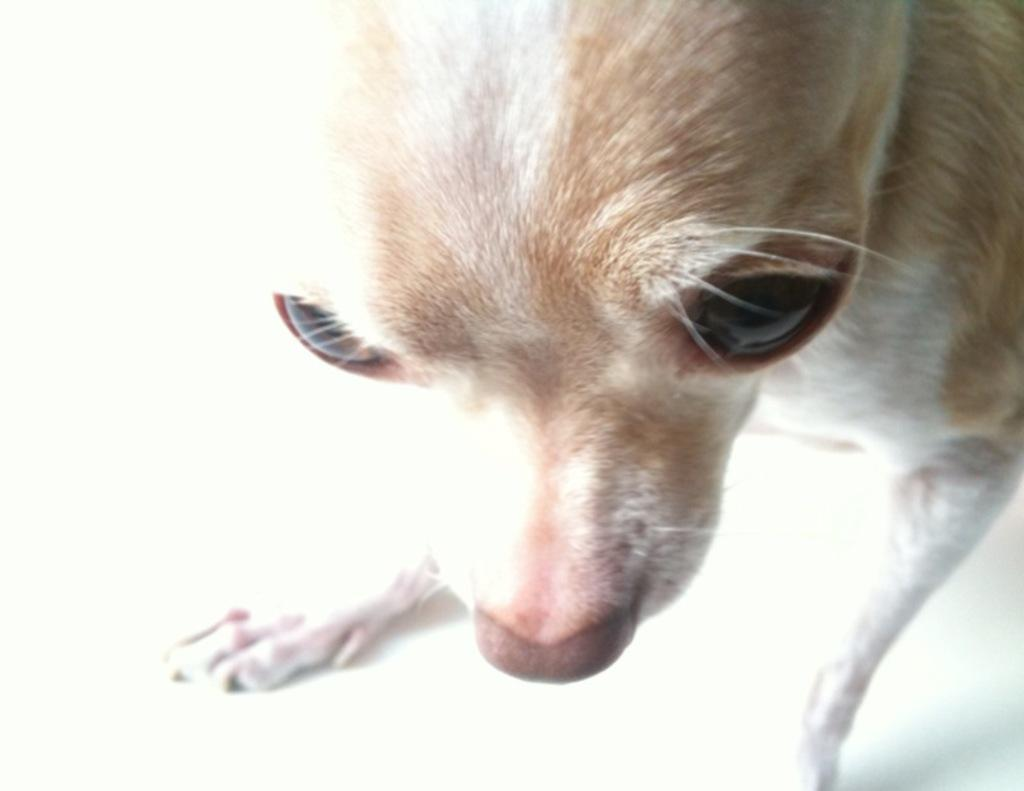What type of creature is present in the image? There is an animal in the image. What are some features of the animal's face? The animal has eyes and a nose. How does the animal move around? The animal has legs. What type of covering does the animal have on its body? The animal has fur. What type of string can be seen tied around the animal's neck in the image? There is no string tied around the animal's neck in the image. Can you hear the animal whistling in the image? There is no indication of sound in the image, so it cannot be determined if the animal is whistling. 